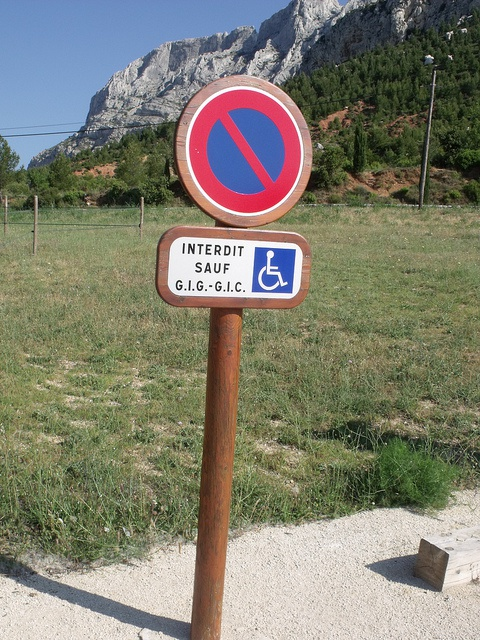Describe the objects in this image and their specific colors. I can see a stop sign in gray, brown, blue, salmon, and lightpink tones in this image. 